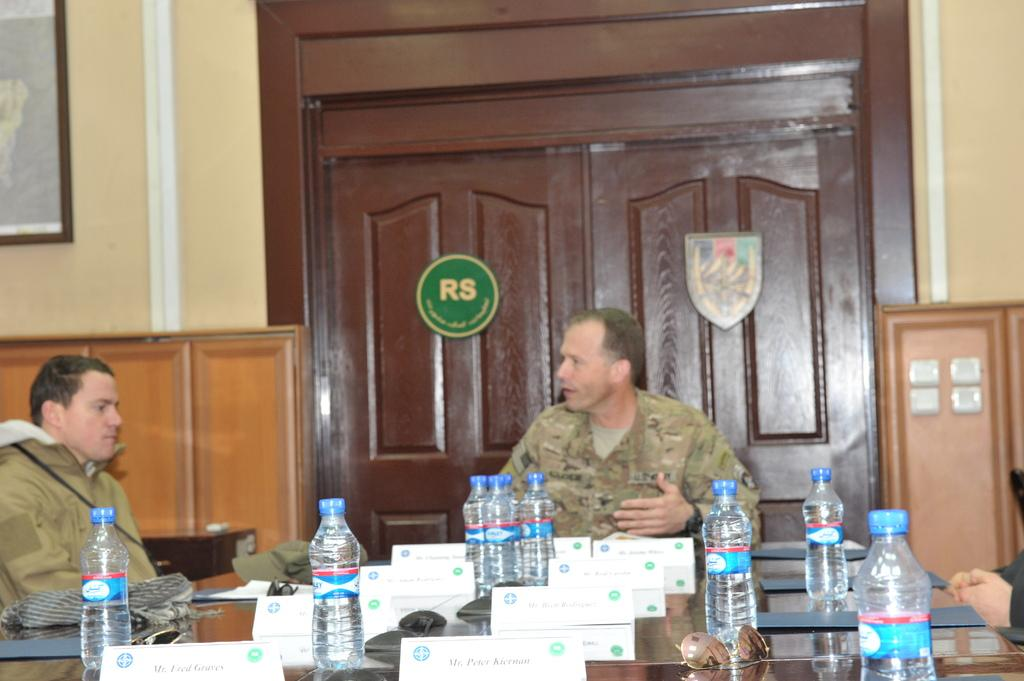<image>
Share a concise interpretation of the image provided. two men sitting at a conference room with a sign RS. 